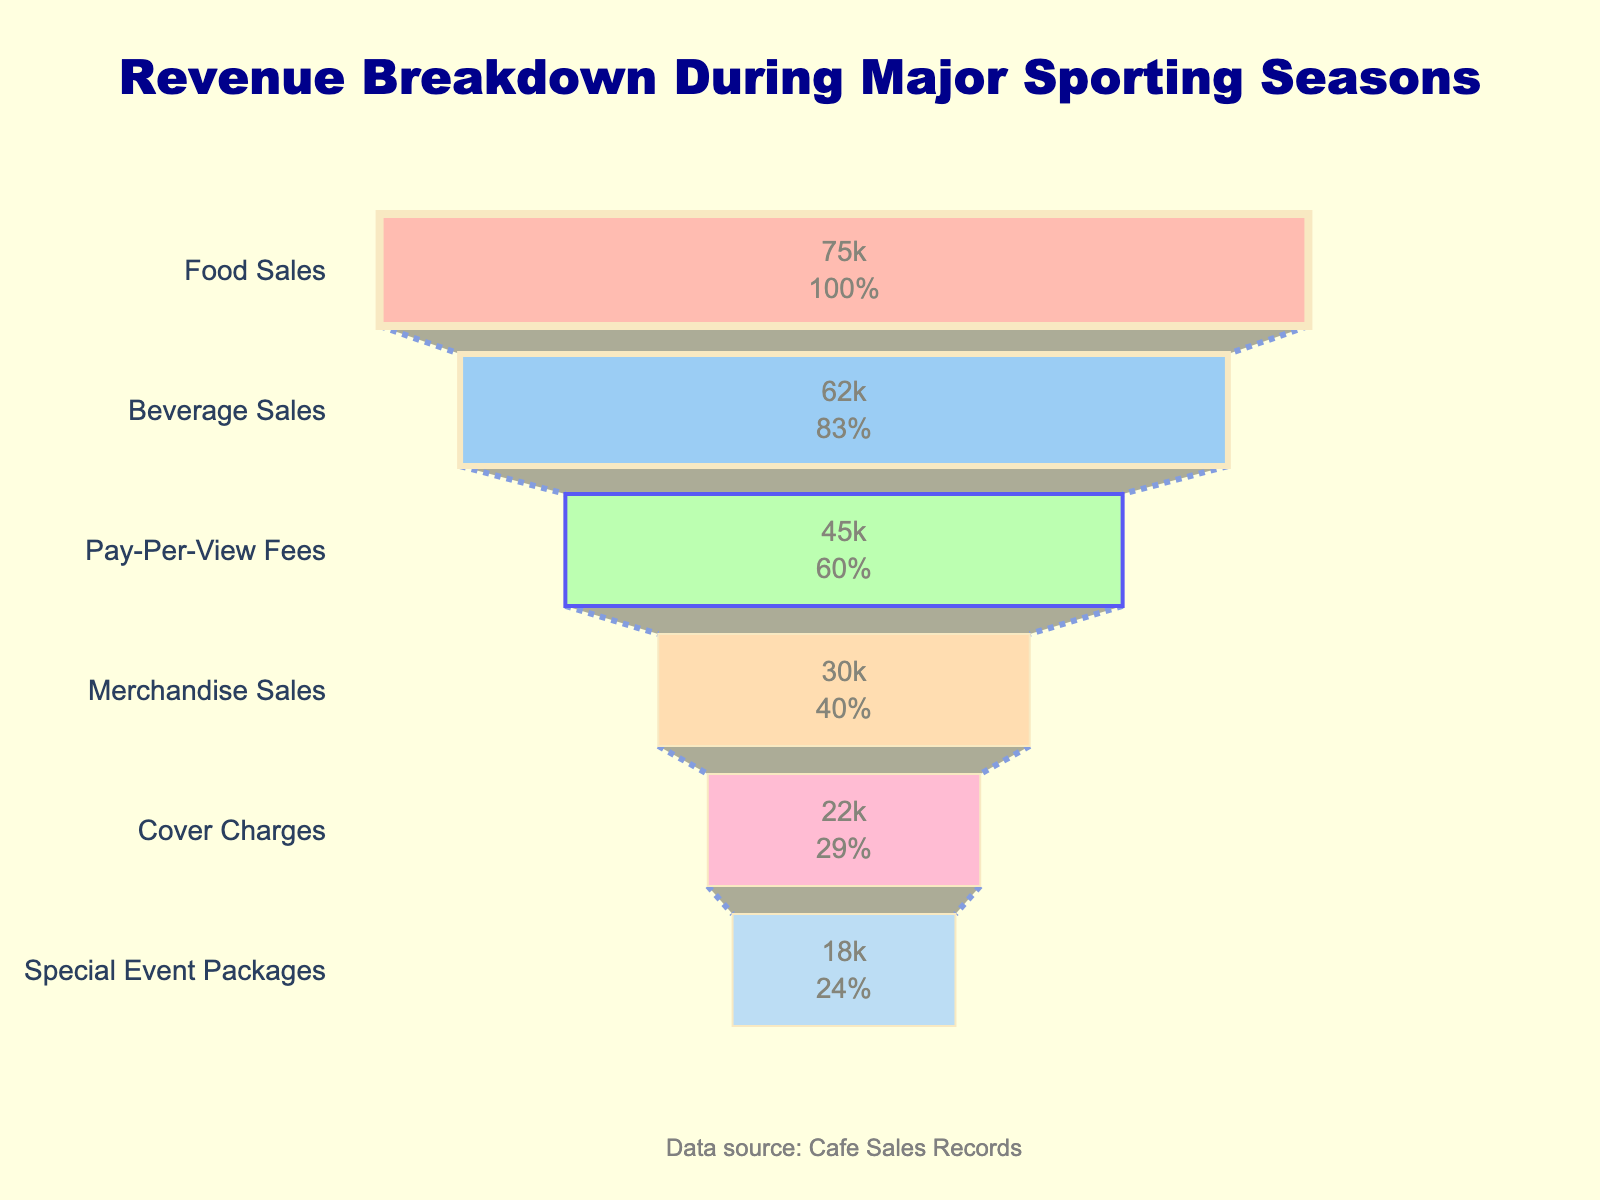What is the title of the funnel chart? The title of the funnel chart is presented at the top of the figure in bold letters. It reads: "Revenue Breakdown During Major Sporting Seasons".
Answer: Revenue Breakdown During Major Sporting Seasons What are the stages with the highest and lowest revenue? The stages with the highest revenue and the lowest revenue are located at the top and the bottom of the funnel chart respectively. The highest is "Food Sales" and the lowest is "Special Event Packages".
Answer: Food Sales and Special Event Packages What percentage of the total revenue comes from Food Sales? First, identify the revenue from Food Sales, which is $75,000. Then, sum all the revenue figures to find the total revenue: $75,000 + $62,000 + $45,000 + $30,000 + $22,000 + $18,000 = $252,000. Finally, calculate the percentage: (75,000 / 252,000) * 100 ≈ 29.8%.
Answer: 29.8% How does the revenue from Food Sales compare to that from Beverage Sales? From the chart, Food Sales are $75,000 and Beverage Sales are $62,000. Calculate the difference: $75,000 - $62,000 = $13,000. Food Sales generate $13,000 more revenue than Beverage Sales.
Answer: $13,000 more If we combine the revenue from Pay-Per-View Fees and Merchandise Sales, what is the total amount? Identify the respective revenues: Pay-Per-View Fees ($45,000) and Merchandise Sales ($30,000). Adding them together gives: $45,000 + $30,000 = $75,000.
Answer: $75,000 What proportion of the total revenue is generated by the bottom three stages (Merchandise Sales, Cover Charges, Special Event Packages)? First, add the revenue from the bottom three stages: $30,000 + $22,000 + $18,000 = $70,000. Then, calculate the total revenue: $252,000. Finally, find the proportion: ($70,000 / $252,000) * 100 ≈ 27.8%.
Answer: 27.8% Which stage is responsible for the smallest portion of the revenue, and what is its percentage contribution? The smallest revenue source is "Special Event Packages" with $18,000. To find its percentage contribution: ($18,000 / $252,000) * 100 ≈ 7.1%.
Answer: Special Event Packages, 7.1% What is the difference in revenue between the stage contributing the most and the stage contributing the least? The highest revenue comes from Food Sales ($75,000) and the lowest from Special Event Packages ($18,000). The difference is $75,000 - $18,000 = $57,000.
Answer: $57,000 Among Food Sales, Beverage Sales, and Pay-Per-View Fees, which source contributes the least to the total revenue? Food Sales ($75,000), Beverage Sales ($62,000), and Pay-Per-View Fees ($45,000). The least contribution comes from Pay-Per-View Fees at $45,000.
Answer: Pay-Per-View Fees 